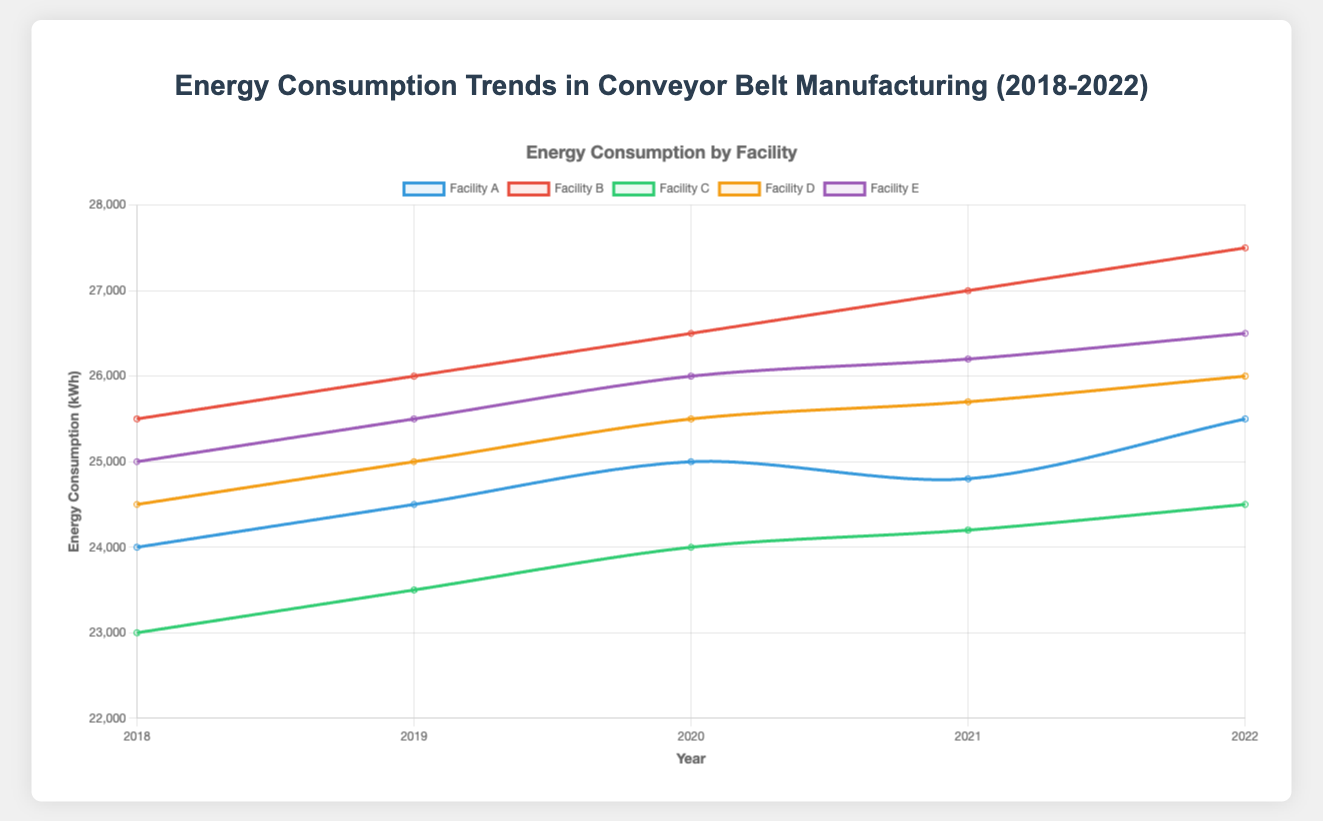What's the energy consumption trend for Facility A from 2018 to 2022? To determine the trend, look at the plotted line for Facility A and observe how it changes over the years. From 2018 to 2022, the energy values are 24000, 24500, 25000, 24800, and 25500 respectively. This shows a slight overall increase with minor fluctuations.
Answer: Slight overall increase Which facility had the highest energy consumption in 2019? Check the peaks of the plotted lines for the year 2019. In 2019, Facility B had the highest consumption at 26000 kWh.
Answer: Facility B Between 2020 and 2021, which facility showed a decrease in energy consumption? Examine changes in the lines between 2020 and 2021. Facility A's energy consumption decreased from 25000 to 24800 kWh.
Answer: Facility A What was the average energy consumption of Facility D over the 5-year period? Calculate the average by summing the energy values for Facility D and dividing by the number of years. (24500 + 25000 + 25500 + 25700 + 26000) / 5 = 25340 kWh.
Answer: 25340 kWh How much more energy did Facility B consume in 2022 compared to Facility C in 2020? find both values and subtract Facility C's 2020 energy from Facility B's 2022 energy. Facility B in 2022 consumed 27500 kWh, and Facility C in 2020 consumed 24000 kWh. The difference is 27500 - 24000 = 3500 kWh.
Answer: 3500 kWh Which facility consistently showed an increase in energy consumption each year? Trace the lines and observe if there is an uninterrupted upward trend. Facility B consistently increased from 25500 to 27500 kWh over the five years.
Answer: Facility B What is the median energy consumption for Facility C from 2018 to 2022? Arrange Facility C's values in order and find the middle value. The sorted values are 23000, 23500, 24000, 24200, 24500. The median is the third value, 24000 kWh.
Answer: 24000 kWh Which year saw the highest aggregate energy consumption across all facilities? Sum the energy consumption values for all facilities per year, then compare. Yearly totals are: 2018: 122000, 2019: 124500, 2020: 127000, 2021: 127400, 2022: 130000. The highest is in 2022.
Answer: 2022 How does the energy consumption of Facility E in 2022 visually compare in color to that of Facility D? Identify the colors representing each facility’s line. Facility E is represented in purple, and Facility D is in orange.
Answer: Purple vs. Orange 